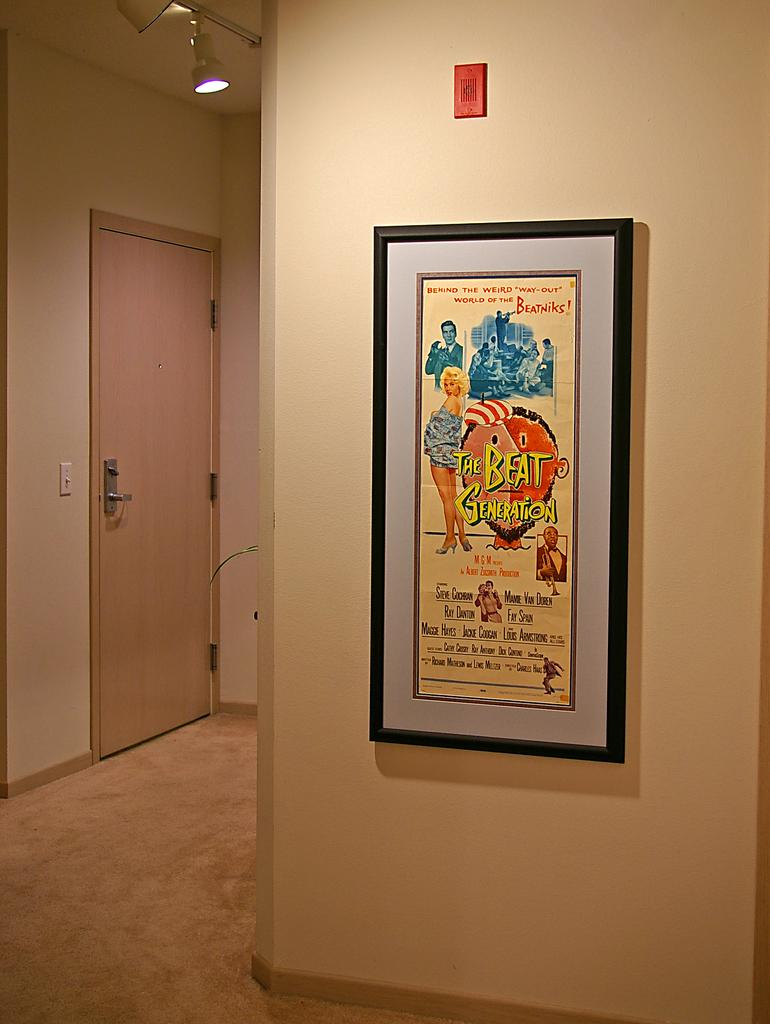<image>
Describe the image concisely. A poster of The Beat Generation hanging on a wall. 